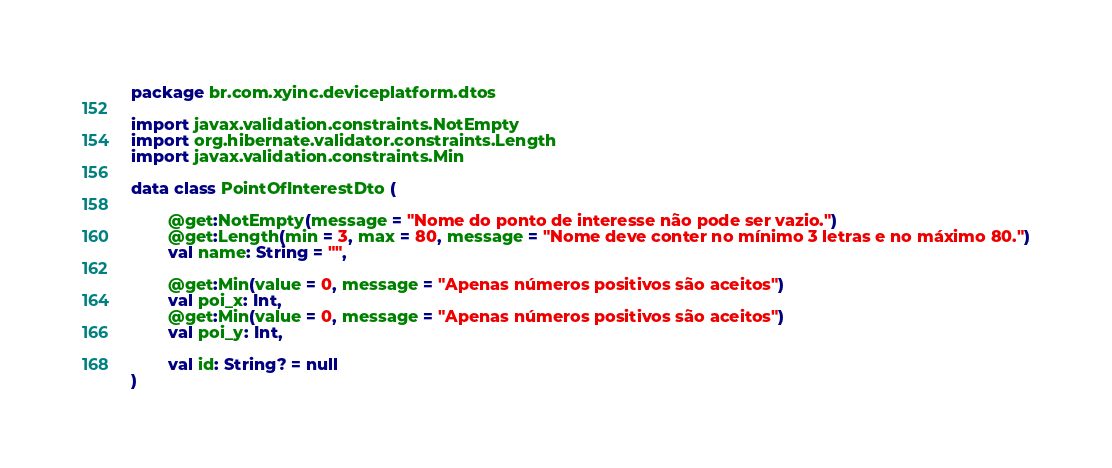Convert code to text. <code><loc_0><loc_0><loc_500><loc_500><_Kotlin_>package br.com.xyinc.deviceplatform.dtos

import javax.validation.constraints.NotEmpty
import org.hibernate.validator.constraints.Length
import javax.validation.constraints.Min

data class PointOfInterestDto (

        @get:NotEmpty(message = "Nome do ponto de interesse não pode ser vazio.")
        @get:Length(min = 3, max = 80, message = "Nome deve conter no mínimo 3 letras e no máximo 80.")
        val name: String = "",

        @get:Min(value = 0, message = "Apenas números positivos são aceitos")
        val poi_x: Int,
        @get:Min(value = 0, message = "Apenas números positivos são aceitos")
        val poi_y: Int,

        val id: String? = null
)</code> 